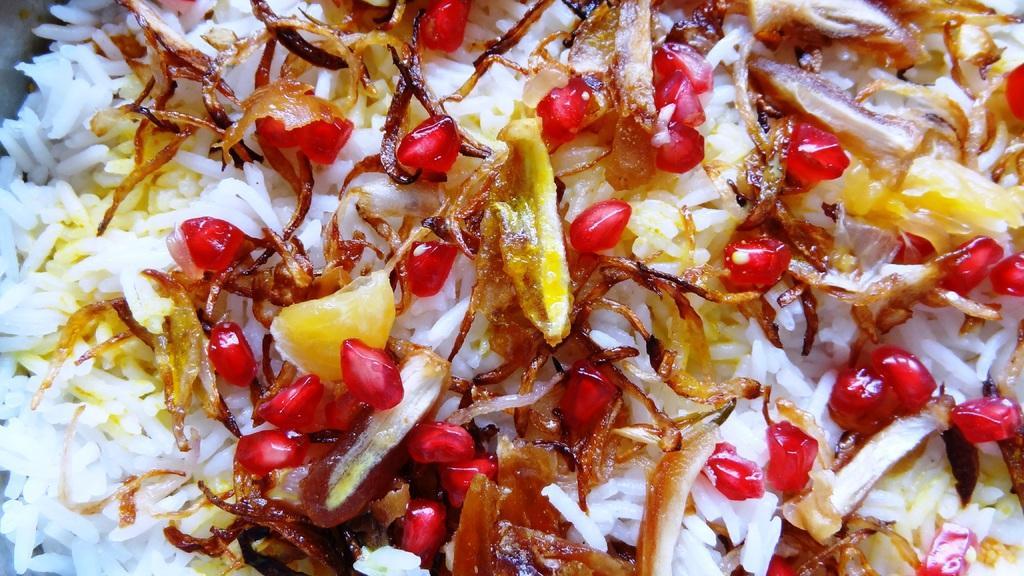How would you summarize this image in a sentence or two? In this image we can see rice on which some fried onions on which group of pomegranate seeds are present. 